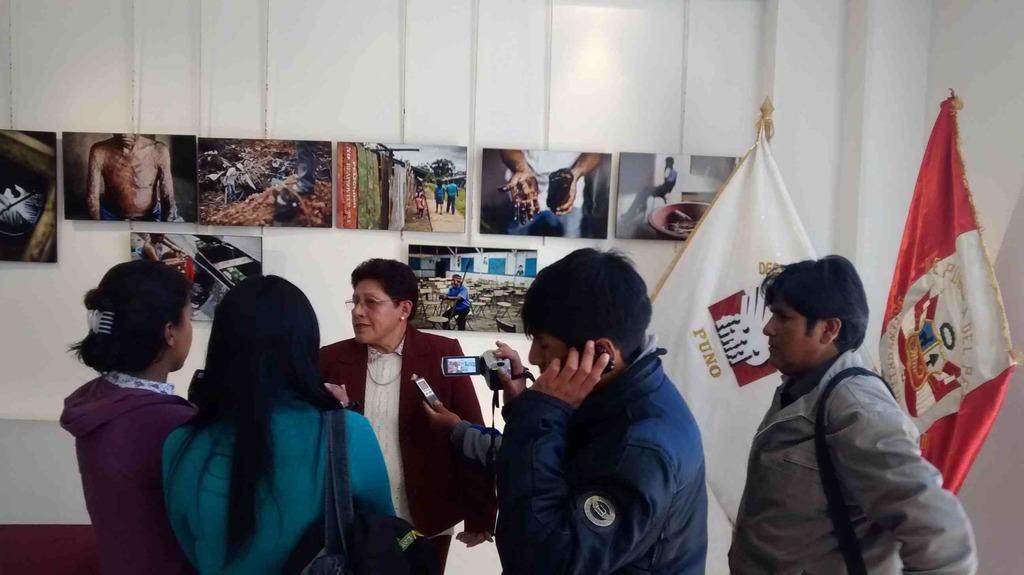In one or two sentences, can you explain what this image depicts? As we can see in the image there is a white color wall, group of people, flags, photos, camera and mobile phone. 